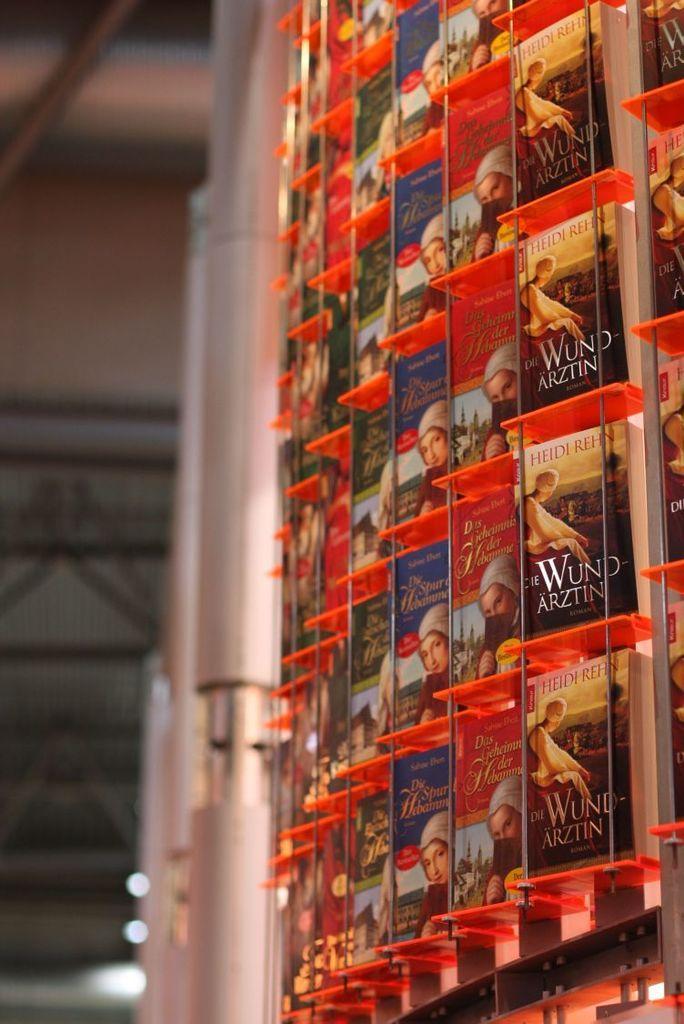Could you give a brief overview of what you see in this image? This image consists of many books, are kept in a rack. At the top, there is a roof. Beside the book, there are rods. 